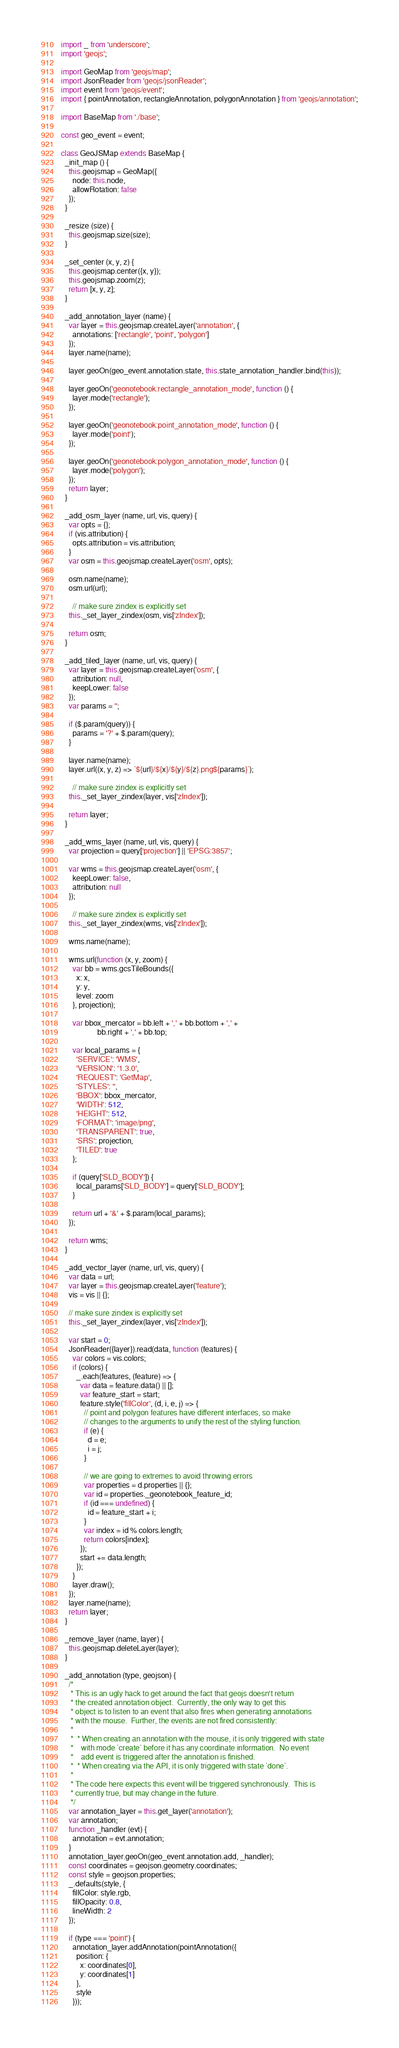Convert code to text. <code><loc_0><loc_0><loc_500><loc_500><_JavaScript_>import _ from 'underscore';
import 'geojs';

import GeoMap from 'geojs/map';
import JsonReader from 'geojs/jsonReader';
import event from 'geojs/event';
import { pointAnnotation, rectangleAnnotation, polygonAnnotation } from 'geojs/annotation';

import BaseMap from './base';

const geo_event = event;

class GeoJSMap extends BaseMap {
  _init_map () {
    this.geojsmap = GeoMap({
      node: this.node,
      allowRotation: false
    });
  }

  _resize (size) {
    this.geojsmap.size(size);
  }

  _set_center (x, y, z) {
    this.geojsmap.center({x, y});
    this.geojsmap.zoom(z);
    return [x, y, z];
  }

  _add_annotation_layer (name) {
    var layer = this.geojsmap.createLayer('annotation', {
      annotations: ['rectangle', 'point', 'polygon']
    });
    layer.name(name);

    layer.geoOn(geo_event.annotation.state, this.state_annotation_handler.bind(this));

    layer.geoOn('geonotebook:rectangle_annotation_mode', function () {
      layer.mode('rectangle');
    });

    layer.geoOn('geonotebook:point_annotation_mode', function () {
      layer.mode('point');
    });

    layer.geoOn('geonotebook:polygon_annotation_mode', function () {
      layer.mode('polygon');
    });
    return layer;
  }

  _add_osm_layer (name, url, vis, query) {
    var opts = {};
    if (vis.attribution) {
      opts.attribution = vis.attribution;
    }
    var osm = this.geojsmap.createLayer('osm', opts);

    osm.name(name);
    osm.url(url);

      // make sure zindex is explicitly set
    this._set_layer_zindex(osm, vis['zIndex']);

    return osm;
  }

  _add_tiled_layer (name, url, vis, query) {
    var layer = this.geojsmap.createLayer('osm', {
      attribution: null,
      keepLower: false
    });
    var params = '';

    if ($.param(query)) {
      params = '?' + $.param(query);
    }

    layer.name(name);
    layer.url((x, y, z) => `${url}/${x}/${y}/${z}.png${params}`);

      // make sure zindex is explicitly set
    this._set_layer_zindex(layer, vis['zIndex']);

    return layer;
  }

  _add_wms_layer (name, url, vis, query) {
    var projection = query['projection'] || 'EPSG:3857';

    var wms = this.geojsmap.createLayer('osm', {
      keepLower: false,
      attribution: null
    });

      // make sure zindex is explicitly set
    this._set_layer_zindex(wms, vis['zIndex']);

    wms.name(name);

    wms.url(function (x, y, zoom) {
      var bb = wms.gcsTileBounds({
        x: x,
        y: y,
        level: zoom
      }, projection);

      var bbox_mercator = bb.left + ',' + bb.bottom + ',' +
                   bb.right + ',' + bb.top;

      var local_params = {
        'SERVICE': 'WMS',
        'VERSION': '1.3.0',
        'REQUEST': 'GetMap',
        'STYLES': '',
        'BBOX': bbox_mercator,
        'WIDTH': 512,
        'HEIGHT': 512,
        'FORMAT': 'image/png',
        'TRANSPARENT': true,
        'SRS': projection,
        'TILED': true
      };

      if (query['SLD_BODY']) {
        local_params['SLD_BODY'] = query['SLD_BODY'];
      }

      return url + '&' + $.param(local_params);
    });

    return wms;
  }

  _add_vector_layer (name, url, vis, query) {
    var data = url;
    var layer = this.geojsmap.createLayer('feature');
    vis = vis || {};

    // make sure zindex is explicitly set
    this._set_layer_zindex(layer, vis['zIndex']);

    var start = 0;
    JsonReader({layer}).read(data, function (features) {
      var colors = vis.colors;
      if (colors) {
        _.each(features, (feature) => {
          var data = feature.data() || [];
          var feature_start = start;
          feature.style('fillColor', (d, i, e, j) => {
            // point and polygon features have different interfaces, so make
            // changes to the arguments to unify the rest of the styling function.
            if (e) {
              d = e;
              i = j;
            }

            // we are going to extremes to avoid throwing errors
            var properties = d.properties || {};
            var id = properties._geonotebook_feature_id;
            if (id === undefined) {
              id = feature_start + i;
            }
            var index = id % colors.length;
            return colors[index];
          });
          start += data.length;
        });
      }
      layer.draw();
    });
    layer.name(name);
    return layer;
  }

  _remove_layer (name, layer) {
    this.geojsmap.deleteLayer(layer);
  }

  _add_annotation (type, geojson) {
    /*
     * This is an ugly hack to get around the fact that geojs doesn't return
     * the created annotation object.  Currently, the only way to get this
     * object is to listen to an event that also fires when generating annotations
     * with the mouse.  Further, the events are not fired consistently:
     *
     *  * When creating an annotation with the mouse, it is only triggered with state
     *    with mode `create` before it has any coordinate information.  No event
     *    add event is triggered after the annotation is finished.
     *  * When creating via the API, it is only triggered with state `done`.
     *
     * The code here expects this event will be triggered synchronously.  This is
     * currently true, but may change in the future.
     */
    var annotation_layer = this.get_layer('annotation');
    var annotation;
    function _handler (evt) {
      annotation = evt.annotation;
    }
    annotation_layer.geoOn(geo_event.annotation.add, _handler);
    const coordinates = geojson.geometry.coordinates;
    const style = geojson.properties;
    _.defaults(style, {
      fillColor: style.rgb,
      fillOpacity: 0.8,
      lineWidth: 2
    });

    if (type === 'point') {
      annotation_layer.addAnnotation(pointAnnotation({
        position: {
          x: coordinates[0],
          y: coordinates[1]
        },
        style
      }));</code> 